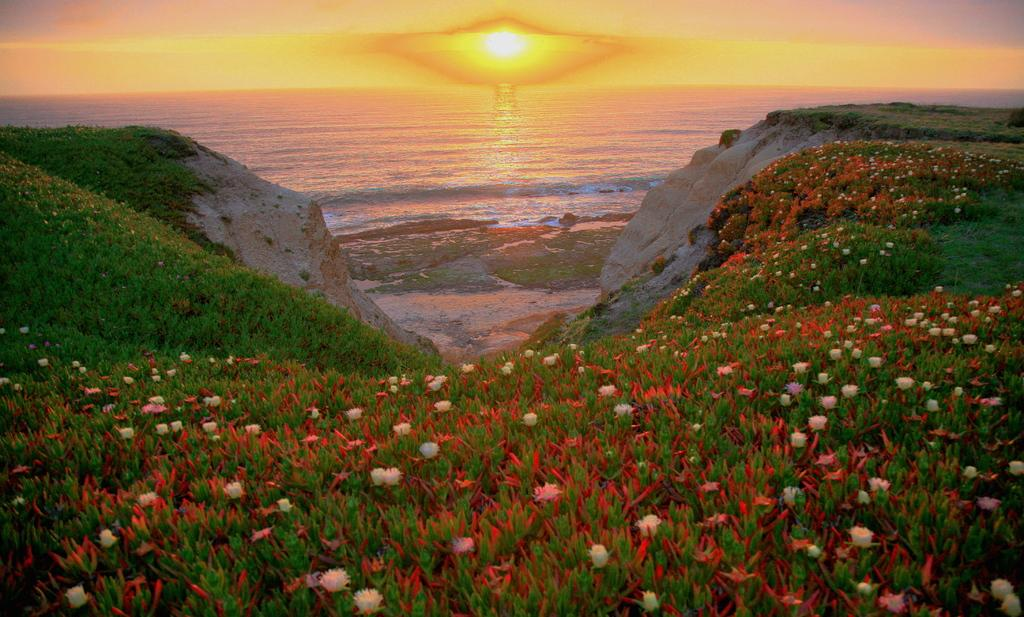What types of living organisms can be seen in the image? Plants and flowers are visible in the image. What natural feature can be seen in the image? There is a river visible in the image. What part of the natural environment is visible in the image? The sky is visible in the image. What type of breakfast is being served in the image? There is no breakfast present in the image; it features plants, flowers, a river, and the sky. 